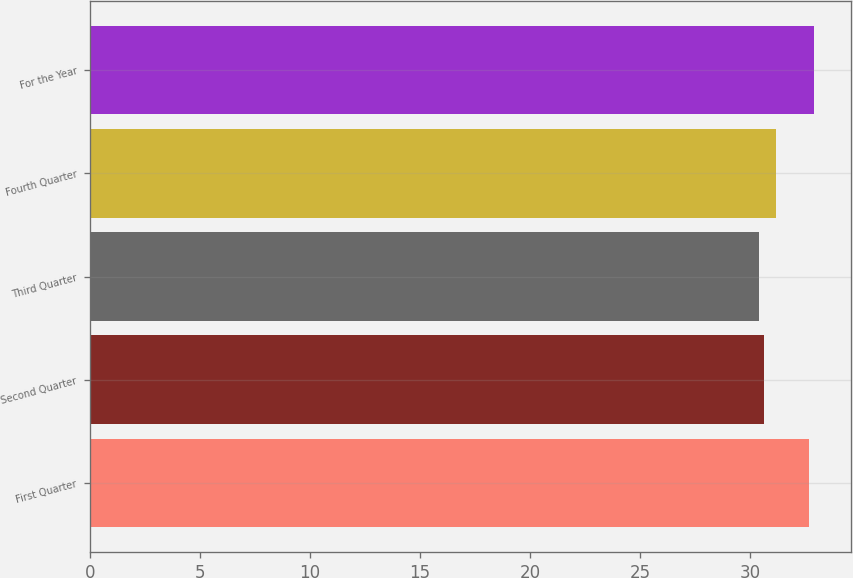Convert chart to OTSL. <chart><loc_0><loc_0><loc_500><loc_500><bar_chart><fcel>First Quarter<fcel>Second Quarter<fcel>Third Quarter<fcel>Fourth Quarter<fcel>For the Year<nl><fcel>32.68<fcel>30.61<fcel>30.38<fcel>31.18<fcel>32.91<nl></chart> 